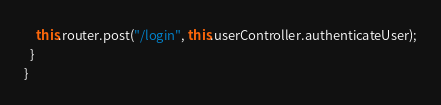<code> <loc_0><loc_0><loc_500><loc_500><_TypeScript_>    this.router.post("/login", this.userController.authenticateUser);
  }
}
</code> 